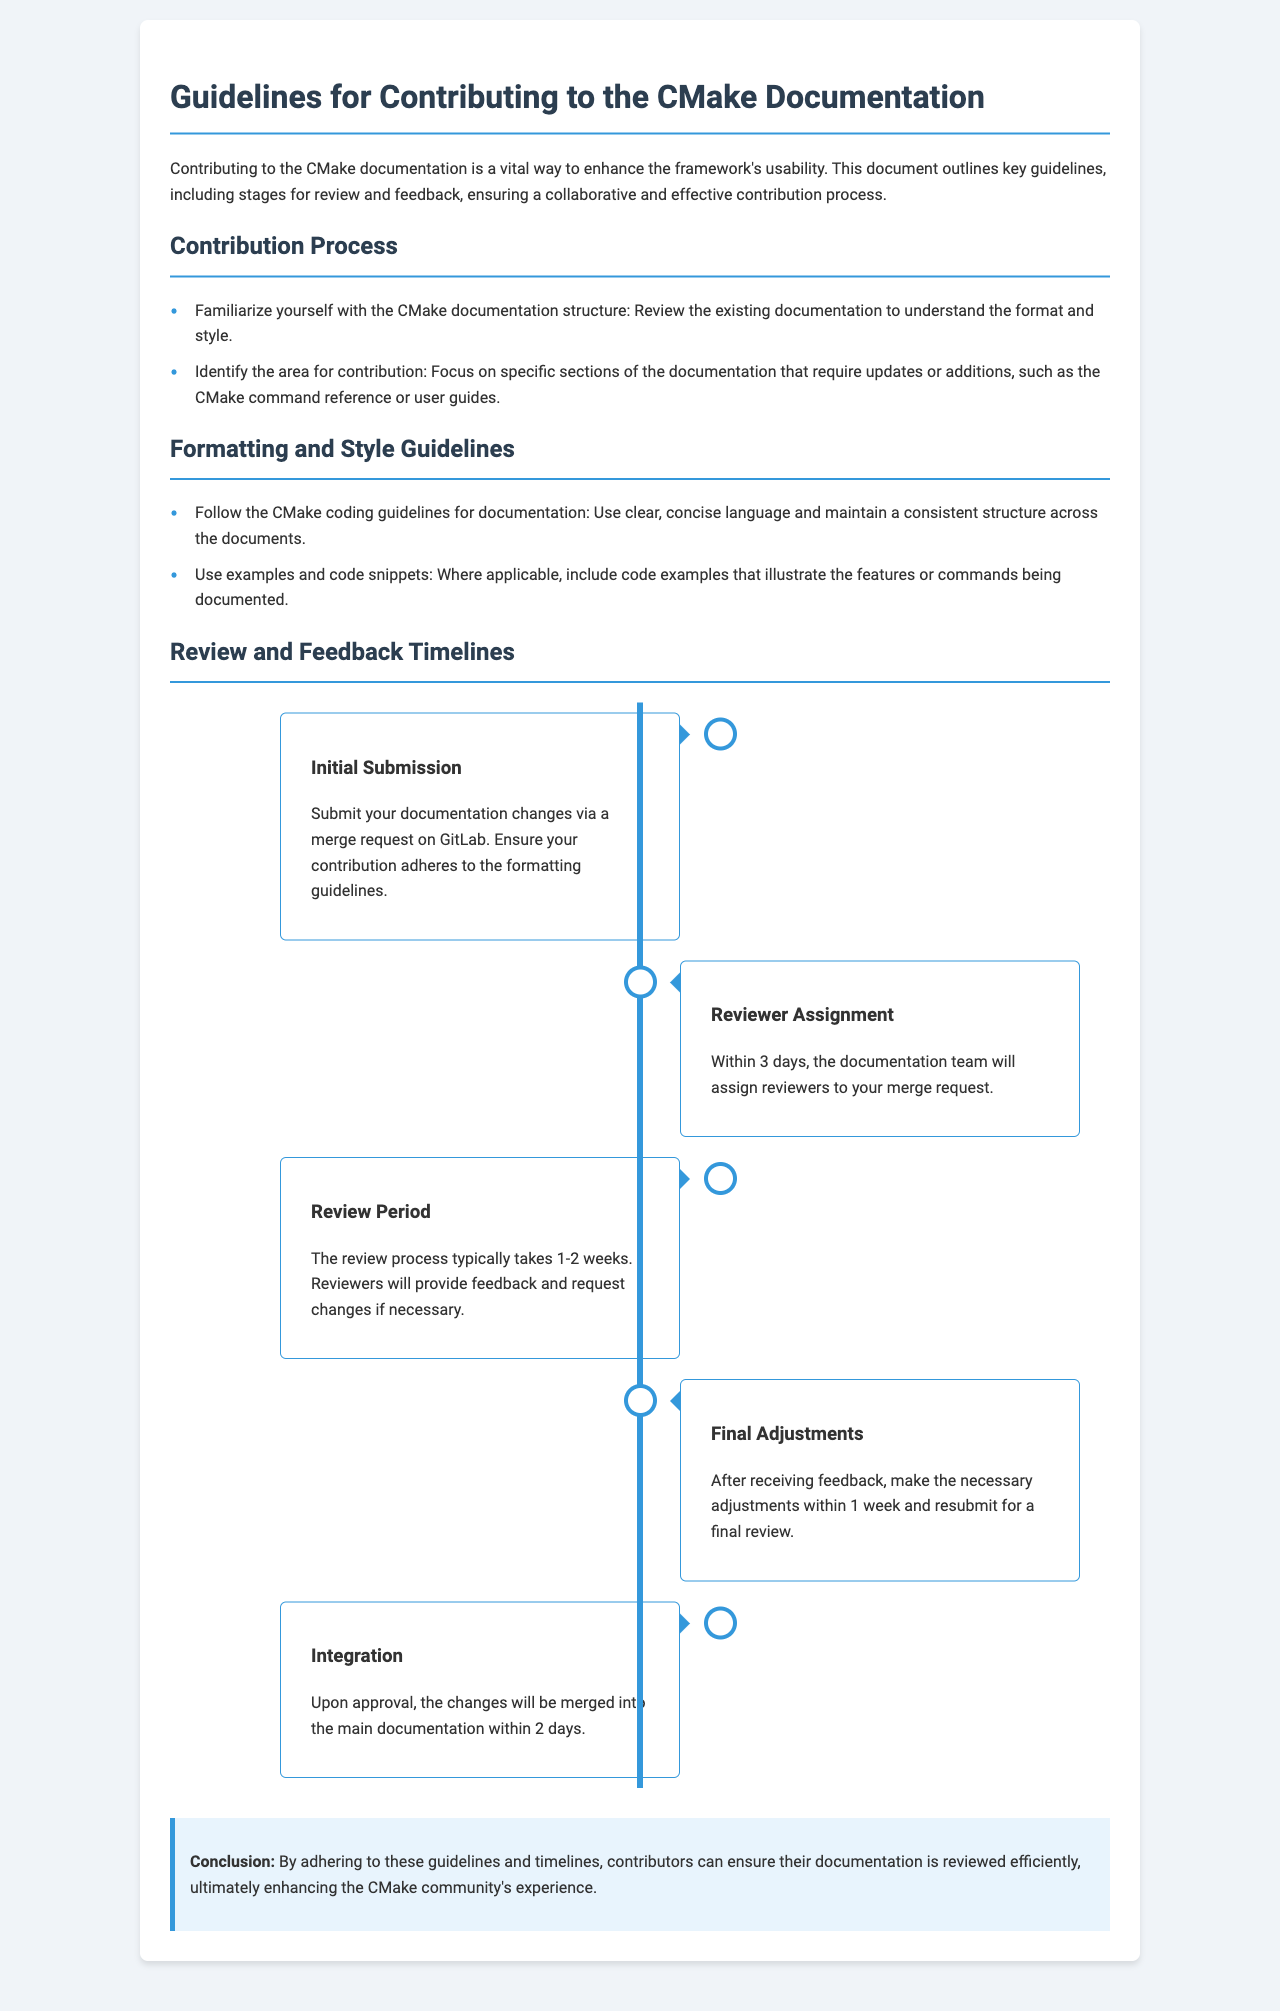What is the first step in the contribution process? The first step involves familiarizing oneself with the CMake documentation structure to understand the format and style.
Answer: Familiarize yourself with the CMake documentation structure How many days does the documentation team take to assign reviewers? The document states that the documentation team will assign reviewers within 3 days of the initial submission.
Answer: 3 days What is the typical duration of the review process? The review process typically lasts 1-2 weeks, according to the guidelines.
Answer: 1-2 weeks How long do contributors have to make final adjustments? After receiving feedback, contributors are given 1 week to make the necessary adjustments.
Answer: 1 week What will happen after the changes are approved? After approval, the changes will be merged into the main documentation within 2 days.
Answer: 2 days What type of contributions does this document focus on? The document focuses on contributions to the CMake documentation.
Answer: CMake documentation What is the purpose of including examples and code snippets? The guideline requires including examples and code snippets to illustrate the features or commands being documented.
Answer: Illustrate features or commands What do contributors need to do before submitting their documentation changes? Contributors should ensure their contribution adheres to the formatting guidelines before submission.
Answer: Adhere to formatting guidelines What is the consequence of failing to follow the guidelines? The document does not specify consequences, but it implies that failing to follow guidelines may hinder the review process.
Answer: Hinder review process 